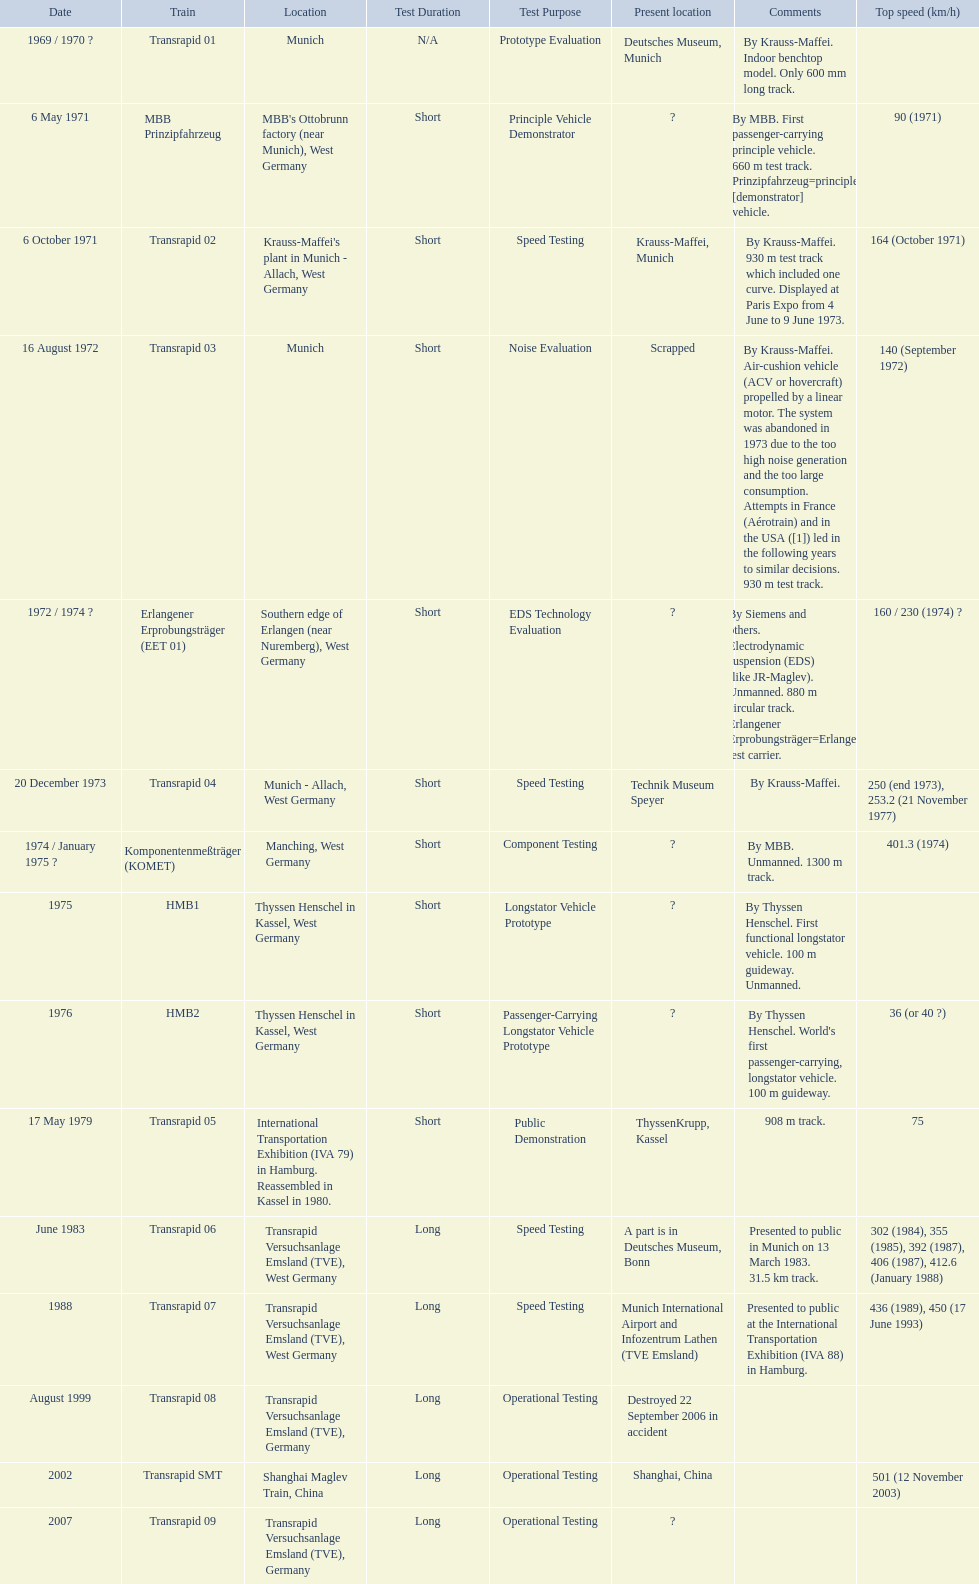What are all of the transrapid trains? Transrapid 01, Transrapid 02, Transrapid 03, Transrapid 04, Transrapid 05, Transrapid 06, Transrapid 07, Transrapid 08, Transrapid SMT, Transrapid 09. Of those, which train had to be scrapped? Transrapid 03. 